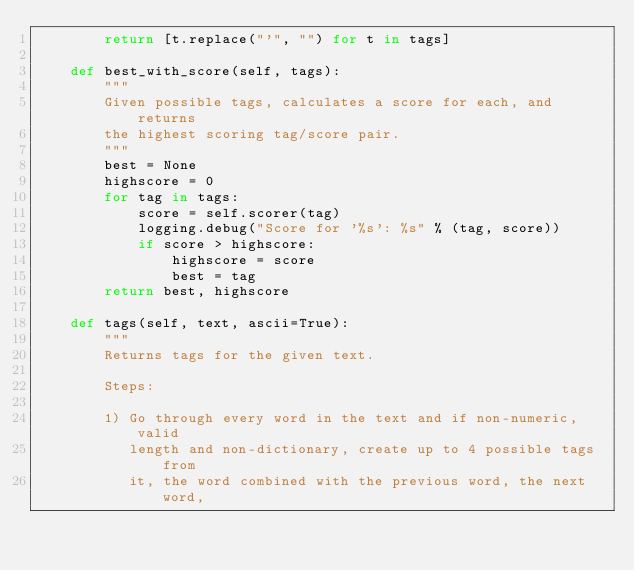Convert code to text. <code><loc_0><loc_0><loc_500><loc_500><_Python_>        return [t.replace("'", "") for t in tags]

    def best_with_score(self, tags):
        """
        Given possible tags, calculates a score for each, and returns
        the highest scoring tag/score pair.
        """
        best = None
        highscore = 0
        for tag in tags:
            score = self.scorer(tag)
            logging.debug("Score for '%s': %s" % (tag, score))
            if score > highscore:
                highscore = score
                best = tag
        return best, highscore

    def tags(self, text, ascii=True):
        """
        Returns tags for the given text.

        Steps:

        1) Go through every word in the text and if non-numeric, valid
           length and non-dictionary, create up to 4 possible tags from
           it, the word combined with the previous word, the next word,</code> 